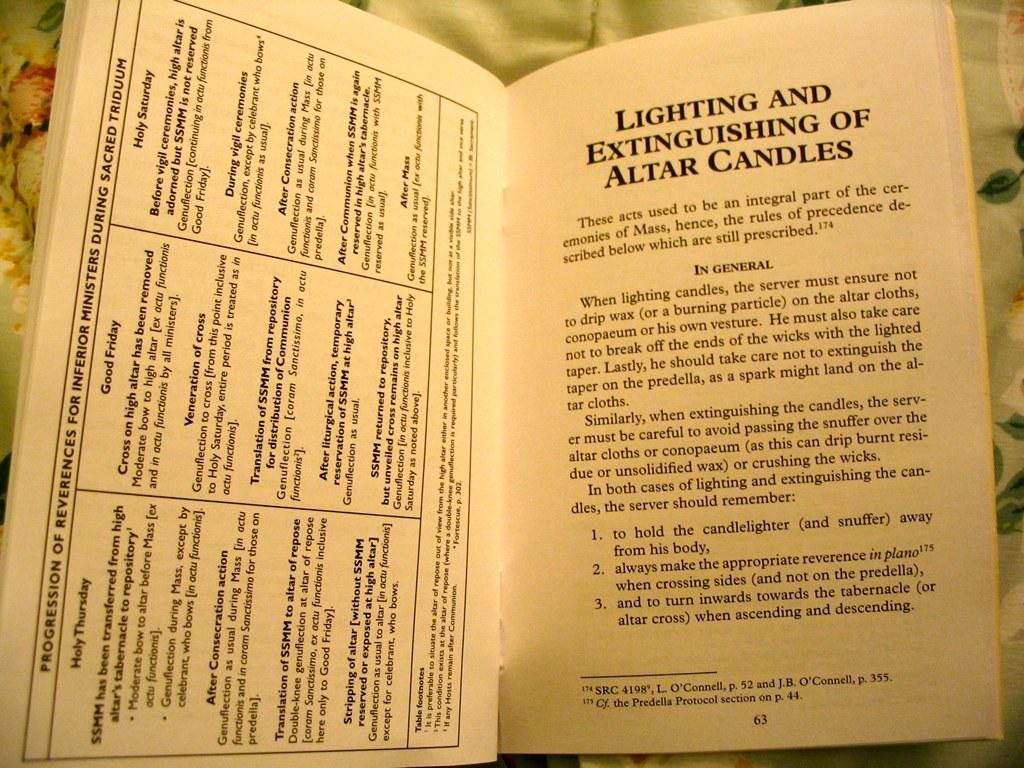<image>
Describe the image concisely. Description on lighting and extinguishing of altar candles 